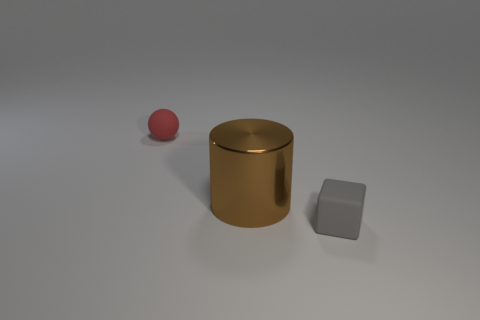What color is the rubber object that is behind the tiny rubber object that is to the right of the big thing?
Your answer should be compact. Red. There is a small object to the right of the matte object that is behind the large brown shiny object; is there a tiny matte object in front of it?
Offer a terse response. No. What color is the tiny object that is the same material as the sphere?
Ensure brevity in your answer.  Gray. How many red things have the same material as the small cube?
Provide a short and direct response. 1. Is the tiny red ball made of the same material as the object that is in front of the large brown shiny object?
Keep it short and to the point. Yes. What number of things are objects that are right of the ball or small red rubber objects?
Provide a short and direct response. 3. There is a rubber thing in front of the tiny matte ball behind the gray rubber object in front of the large brown metal thing; what is its size?
Your answer should be very brief. Small. Are there any other things that are the same shape as the tiny gray matte object?
Make the answer very short. No. What is the size of the matte thing that is left of the tiny object to the right of the brown shiny object?
Your answer should be very brief. Small. What number of large things are either red matte things or blue metallic things?
Make the answer very short. 0. 